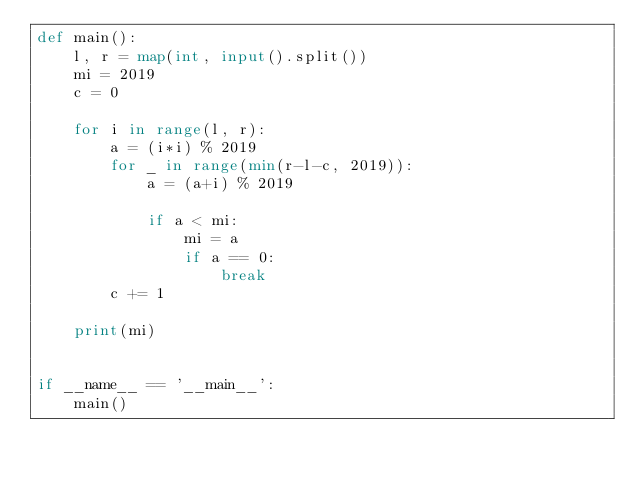<code> <loc_0><loc_0><loc_500><loc_500><_Python_>def main():
    l, r = map(int, input().split())
    mi = 2019
    c = 0

    for i in range(l, r):
        a = (i*i) % 2019
        for _ in range(min(r-l-c, 2019)):
            a = (a+i) % 2019

            if a < mi:
                mi = a
                if a == 0:
                    break
        c += 1

    print(mi)


if __name__ == '__main__':
    main()
</code> 